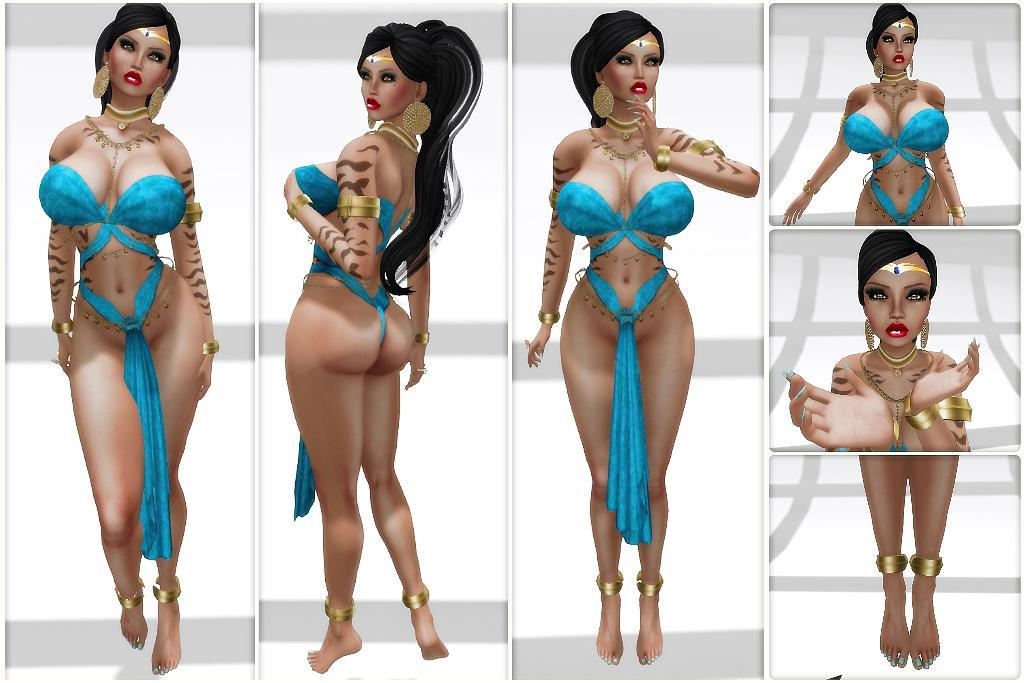What is the main subject of the image? There is a woman in the image. What is the woman wearing? The woman is wearing a blue dress. How many curves can be seen on the mitten in the image? There is no mitten present in the image, so it is not possible to determine the number of curves on it. 